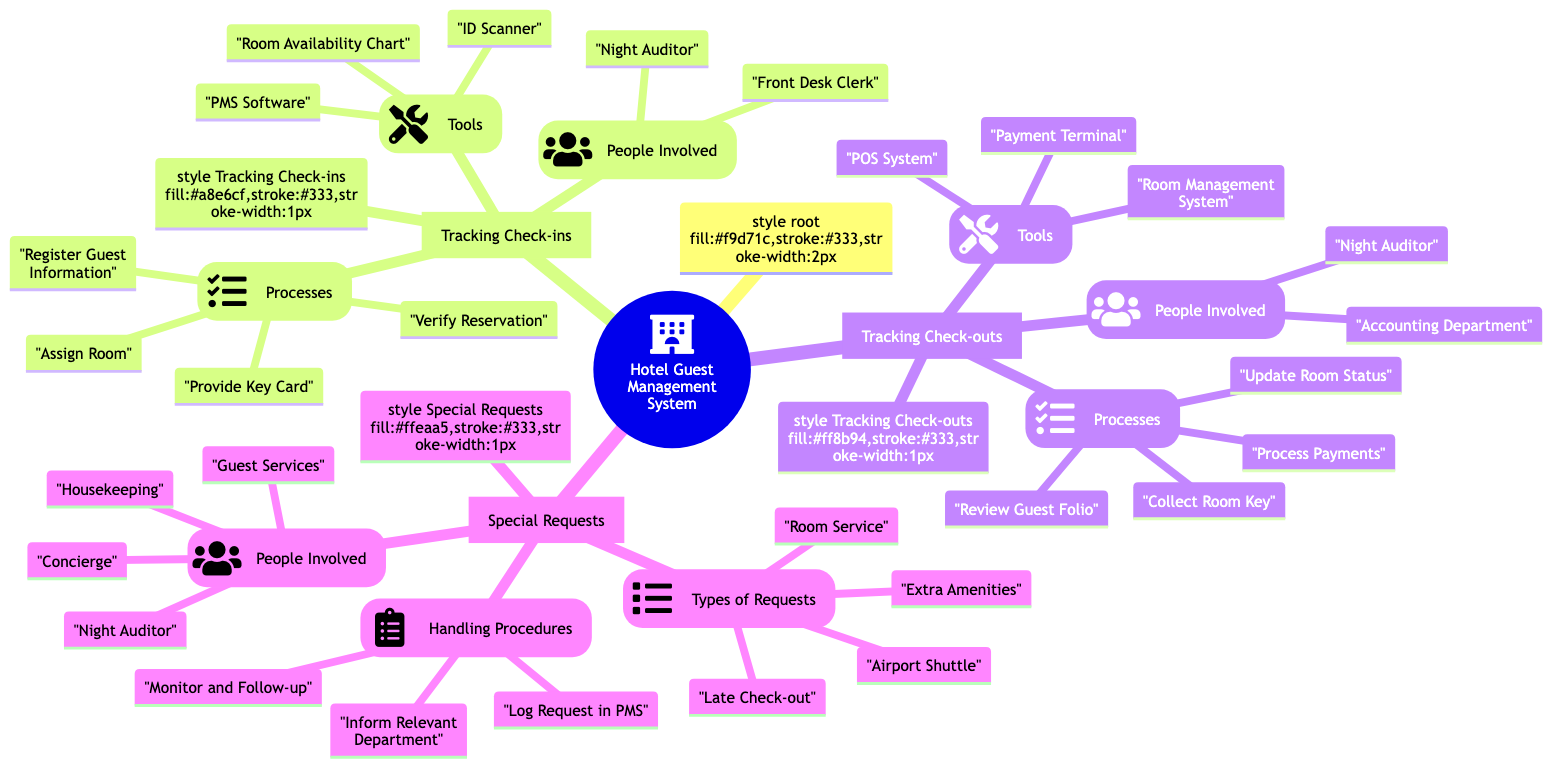What processes are involved in Tracking Check-ins? The diagram lists four specific processes under Tracking Check-ins: Verify Reservation, Register Guest Information, Assign Room, and Provide Key Card. These processes represent the steps taken during the check-in phase for hotel guests.
Answer: Verify Reservation, Register Guest Information, Assign Room, Provide Key Card How many types of special requests are identified? The diagram specifies four types of special requests: Extra Amenities, Room Service, Late Check-out, and Airport Shuttle. Thus, the total count of identified request types is four.
Answer: 4 Who is responsible for handling special requests? The diagram indicates that there are four people/groups involved in handling special requests: Night Auditor, Guest Services, Housekeeping, and Concierge. This denotes their roles in managing guest requests.
Answer: Night Auditor, Guest Services, Housekeeping, Concierge What tool is used to process guest payments at check-out? According to the diagram, the Payment Terminal is specified as a tool utilized for processing payments during the check-out process, indicating its importance in the financial transactions.
Answer: Payment Terminal Which role is involved in both check-ins and check-outs? The diagram highlights that the Night Auditor is named in both the Tracking Check-ins and Tracking Check-outs sections, suggesting their key role across both processes in guest management.
Answer: Night Auditor What is the first process listed under Tracking Check-outs? The first process outlined in the Tracking Check-outs section is "Review Guest Folio", indicating it is the initial step taken when a guest is ready to check out.
Answer: Review Guest Folio How are special requests logged? The diagram mentions that special requests are logged in the PMS, which indicates the system through which requests are officially recorded for tracking and fulfillment purposes.
Answer: Log Request in PMS What tools are listed under Tracking Check-ins? The diagram identifies three tools used in Tracking Check-ins: PMS Software, ID Scanner, and Room Availability Chart. These are the resources utilized during the check-in process.
Answer: PMS Software, ID Scanner, Room Availability Chart 